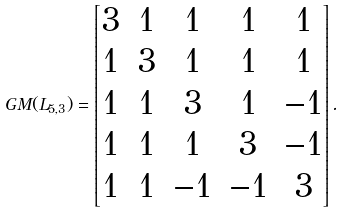<formula> <loc_0><loc_0><loc_500><loc_500>G M ( L _ { 5 , 3 } ) = \left [ \begin{matrix} 3 & 1 & 1 & 1 & 1 \\ 1 & 3 & 1 & 1 & 1 \\ 1 & 1 & 3 & 1 & - 1 \\ 1 & 1 & 1 & 3 & - 1 \\ 1 & 1 & - 1 & - 1 & 3 \end{matrix} \right ] .</formula> 